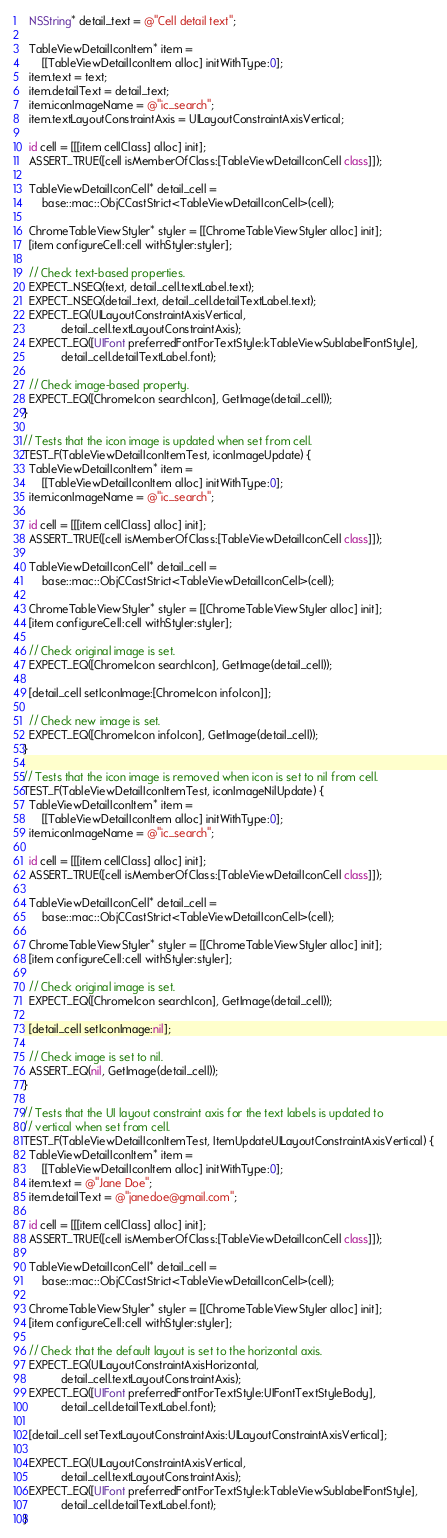<code> <loc_0><loc_0><loc_500><loc_500><_ObjectiveC_>  NSString* detail_text = @"Cell detail text";

  TableViewDetailIconItem* item =
      [[TableViewDetailIconItem alloc] initWithType:0];
  item.text = text;
  item.detailText = detail_text;
  item.iconImageName = @"ic_search";
  item.textLayoutConstraintAxis = UILayoutConstraintAxisVertical;

  id cell = [[[item cellClass] alloc] init];
  ASSERT_TRUE([cell isMemberOfClass:[TableViewDetailIconCell class]]);

  TableViewDetailIconCell* detail_cell =
      base::mac::ObjCCastStrict<TableViewDetailIconCell>(cell);

  ChromeTableViewStyler* styler = [[ChromeTableViewStyler alloc] init];
  [item configureCell:cell withStyler:styler];

  // Check text-based properties.
  EXPECT_NSEQ(text, detail_cell.textLabel.text);
  EXPECT_NSEQ(detail_text, detail_cell.detailTextLabel.text);
  EXPECT_EQ(UILayoutConstraintAxisVertical,
            detail_cell.textLayoutConstraintAxis);
  EXPECT_EQ([UIFont preferredFontForTextStyle:kTableViewSublabelFontStyle],
            detail_cell.detailTextLabel.font);

  // Check image-based property.
  EXPECT_EQ([ChromeIcon searchIcon], GetImage(detail_cell));
}

// Tests that the icon image is updated when set from cell.
TEST_F(TableViewDetailIconItemTest, iconImageUpdate) {
  TableViewDetailIconItem* item =
      [[TableViewDetailIconItem alloc] initWithType:0];
  item.iconImageName = @"ic_search";

  id cell = [[[item cellClass] alloc] init];
  ASSERT_TRUE([cell isMemberOfClass:[TableViewDetailIconCell class]]);

  TableViewDetailIconCell* detail_cell =
      base::mac::ObjCCastStrict<TableViewDetailIconCell>(cell);

  ChromeTableViewStyler* styler = [[ChromeTableViewStyler alloc] init];
  [item configureCell:cell withStyler:styler];

  // Check original image is set.
  EXPECT_EQ([ChromeIcon searchIcon], GetImage(detail_cell));

  [detail_cell setIconImage:[ChromeIcon infoIcon]];

  // Check new image is set.
  EXPECT_EQ([ChromeIcon infoIcon], GetImage(detail_cell));
}

// Tests that the icon image is removed when icon is set to nil from cell.
TEST_F(TableViewDetailIconItemTest, iconImageNilUpdate) {
  TableViewDetailIconItem* item =
      [[TableViewDetailIconItem alloc] initWithType:0];
  item.iconImageName = @"ic_search";

  id cell = [[[item cellClass] alloc] init];
  ASSERT_TRUE([cell isMemberOfClass:[TableViewDetailIconCell class]]);

  TableViewDetailIconCell* detail_cell =
      base::mac::ObjCCastStrict<TableViewDetailIconCell>(cell);

  ChromeTableViewStyler* styler = [[ChromeTableViewStyler alloc] init];
  [item configureCell:cell withStyler:styler];

  // Check original image is set.
  EXPECT_EQ([ChromeIcon searchIcon], GetImage(detail_cell));

  [detail_cell setIconImage:nil];

  // Check image is set to nil.
  ASSERT_EQ(nil, GetImage(detail_cell));
}

// Tests that the UI layout constraint axis for the text labels is updated to
// vertical when set from cell.
TEST_F(TableViewDetailIconItemTest, ItemUpdateUILayoutConstraintAxisVertical) {
  TableViewDetailIconItem* item =
      [[TableViewDetailIconItem alloc] initWithType:0];
  item.text = @"Jane Doe";
  item.detailText = @"janedoe@gmail.com";

  id cell = [[[item cellClass] alloc] init];
  ASSERT_TRUE([cell isMemberOfClass:[TableViewDetailIconCell class]]);

  TableViewDetailIconCell* detail_cell =
      base::mac::ObjCCastStrict<TableViewDetailIconCell>(cell);

  ChromeTableViewStyler* styler = [[ChromeTableViewStyler alloc] init];
  [item configureCell:cell withStyler:styler];

  // Check that the default layout is set to the horizontal axis.
  EXPECT_EQ(UILayoutConstraintAxisHorizontal,
            detail_cell.textLayoutConstraintAxis);
  EXPECT_EQ([UIFont preferredFontForTextStyle:UIFontTextStyleBody],
            detail_cell.detailTextLabel.font);

  [detail_cell setTextLayoutConstraintAxis:UILayoutConstraintAxisVertical];

  EXPECT_EQ(UILayoutConstraintAxisVertical,
            detail_cell.textLayoutConstraintAxis);
  EXPECT_EQ([UIFont preferredFontForTextStyle:kTableViewSublabelFontStyle],
            detail_cell.detailTextLabel.font);
}
</code> 